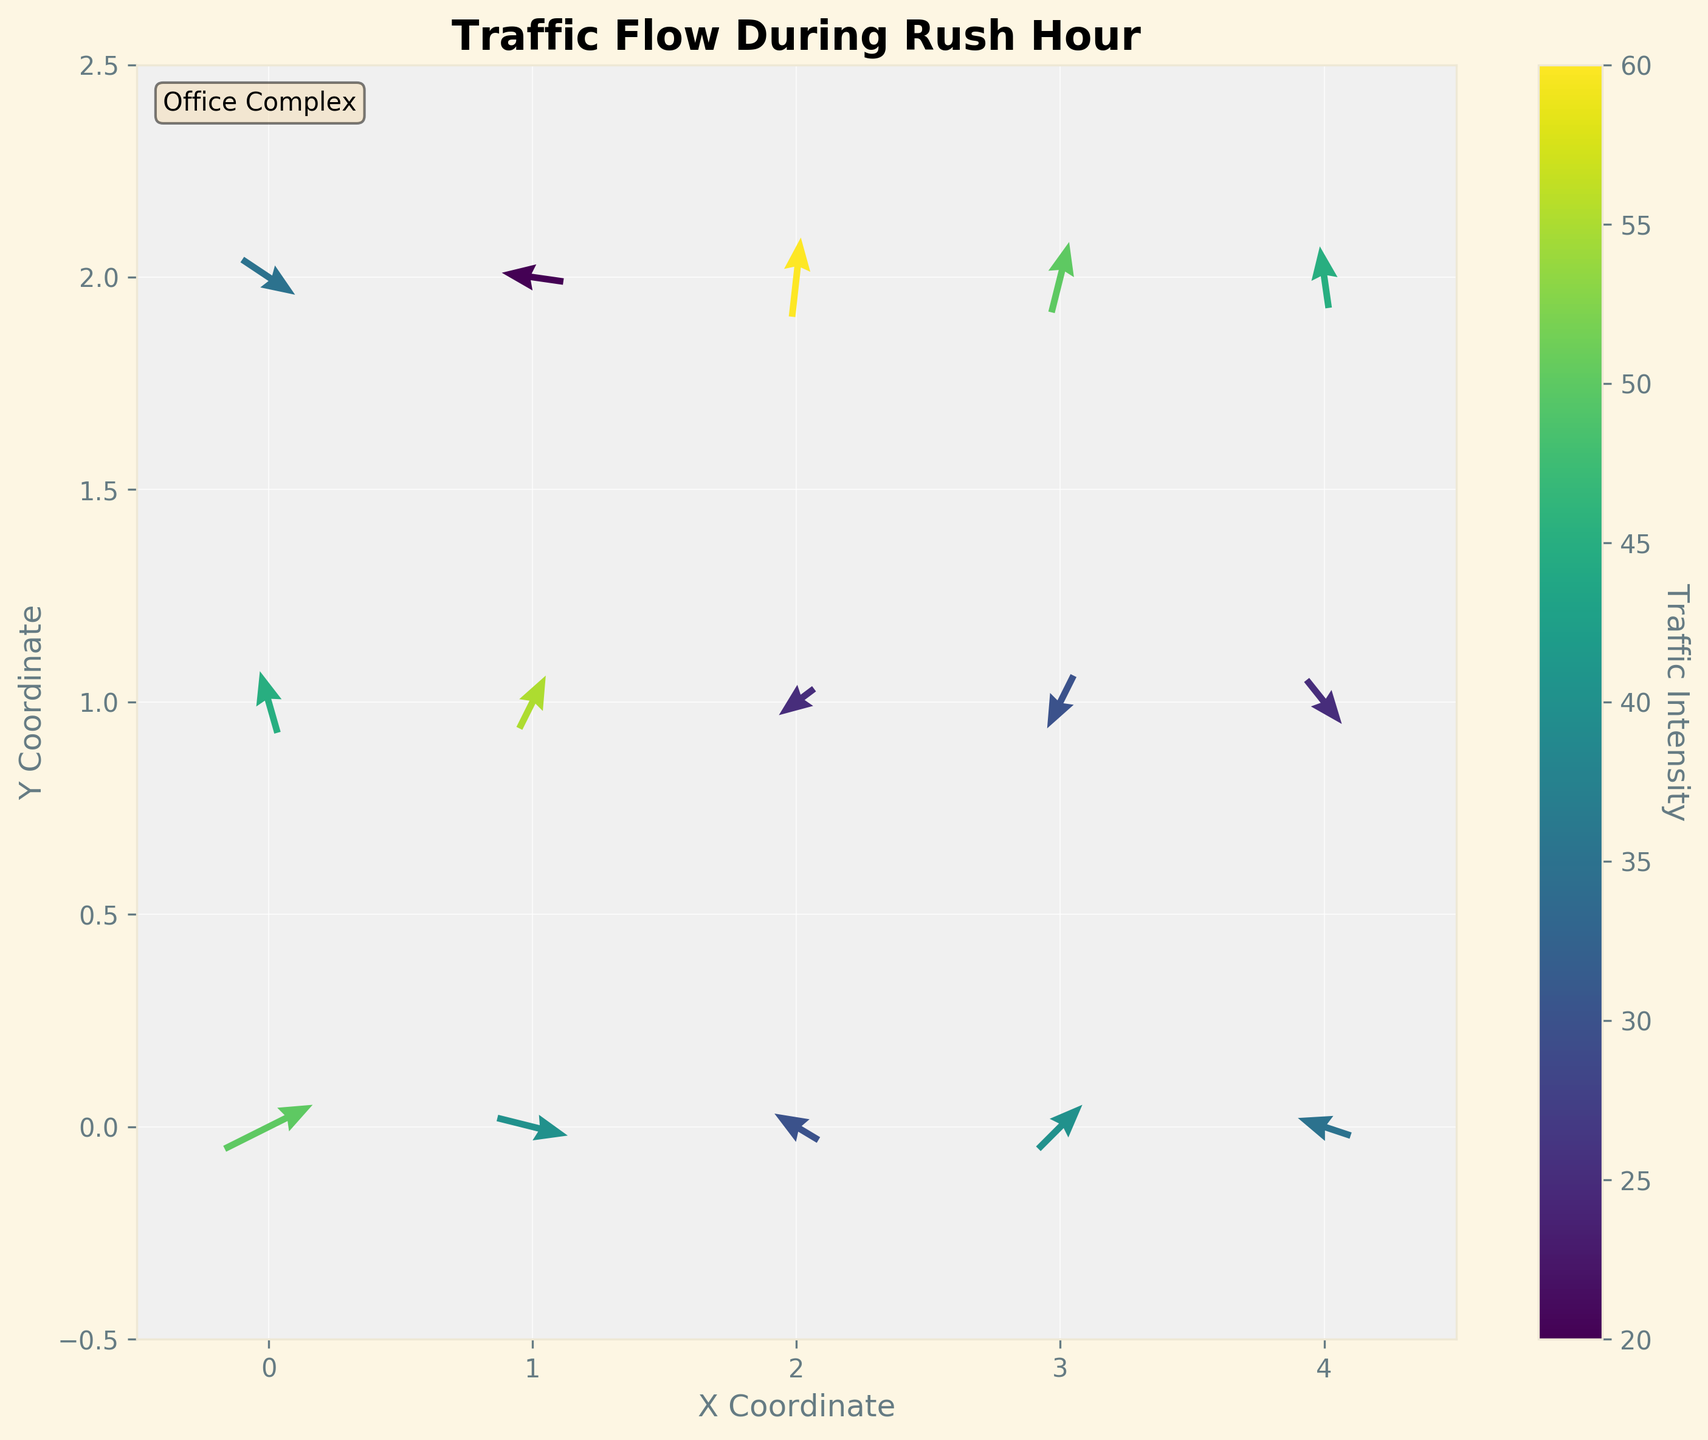What's the title of the figure? The title is displayed prominently at the top of the figure and it reads "Traffic Flow During Rush Hour".
Answer: Traffic Flow During Rush Hour How is the traffic intensity represented in the figure? Traffic intensity is represented by the color of the arrows, with a colorbar indicating the range of intensity values. The color varies from dark to bright depending on the intensity levels.
Answer: By color of the arrows What direction is the arrow at coordinates (0, 1) pointing? To determine the direction of the arrow at (0, 1), observe the arrow's orientation. The arrow vector indicates a direction of approximately left and upward, corresponding to u = -0.2 and v = 0.7.
Answer: Left and up Which location has the highest traffic intensity? To find the location with the highest traffic intensity, check the arrows' colors corresponding to the highest value on the color scale. The coordinates (2, 2) display the brightest color, corresponding to the highest traffic intensity value of 60.
Answer: (2, 2) Compare the traffic direction at coordinates (1, 2) and (3, 1). How do they differ? For coordinates (1, 2), the arrow points left with a slight down-tick, while at (3, 1), the arrow points left and downward. These directions differ significantly in their vertical components but share a leftward horizontal component.
Answer: Differ in vertical component What is the average traffic intensity for the arrows along the x-coordinate 3? The intensities for arrows along x = 3 are 40, 30, and 50. The average is calculated as (40 + 30 + 50) / 3 = 120 / 3 = 40.
Answer: 40 Is there more eastward or westward traffic flow overall? Summing eastward traffic (positive u components) gives values like 1, 0.8, 0.3, 0.6, 0.5, 0.2, 0.4, totaling around 3.8. Summing westward traffic (negative u components) gives -0.5, -0.2, -0.4, -0.7, -0.6, -0.3, -0.1, totaling -2.8. Eastward flow is more prevalent.
Answer: Eastward What is the traffic intensity range in the figure? The traffic intensities in the data range from the minimum value of 20 to the maximum value of 60, as seen on the colorbar.
Answer: 20 to 60 Which coordinate has traffic flowing directly downwards? To determine this, look for an arrow pointing straight downwards (only negative v-component, u = 0). The coordinate (3, 1) has an arrow with u = -0.3 and v = -0.6 indicating primarily downward flow.
Answer: (3, 1) What could be the significance of high traffic intensity at (2, 2)? High traffic intensity at (2, 2) indicates a key traffic point, possibly an entry/exit point or a major intersection within the office complex during rush hour. This position has the highest intensity of 60, suggesting it's a critical area for traffic flow.
Answer: Major intersection/entry-exit point 